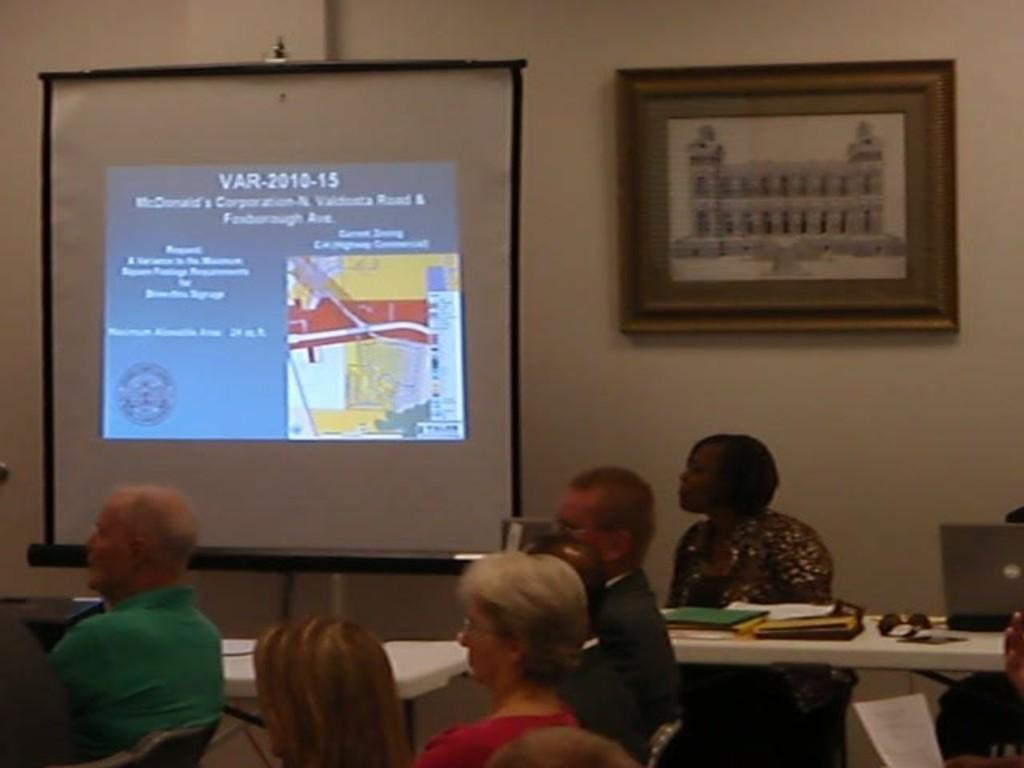Can you describe this image briefly? This picture describes about group of people they are all seated on the chair, in front of them we can see couple of files, glasses, laptop on the table, and also we can see a projector screen and a wall frame on the wall. 